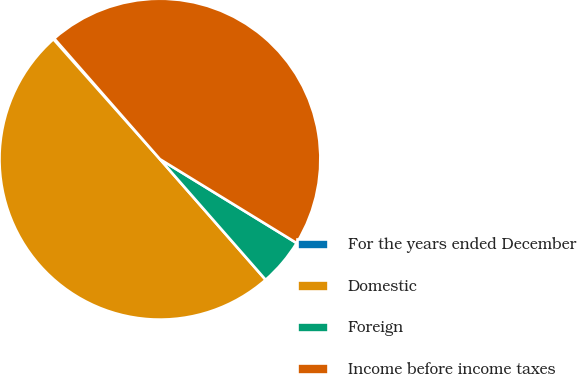<chart> <loc_0><loc_0><loc_500><loc_500><pie_chart><fcel>For the years ended December<fcel>Domestic<fcel>Foreign<fcel>Income before income taxes<nl><fcel>0.11%<fcel>49.89%<fcel>4.79%<fcel>45.21%<nl></chart> 